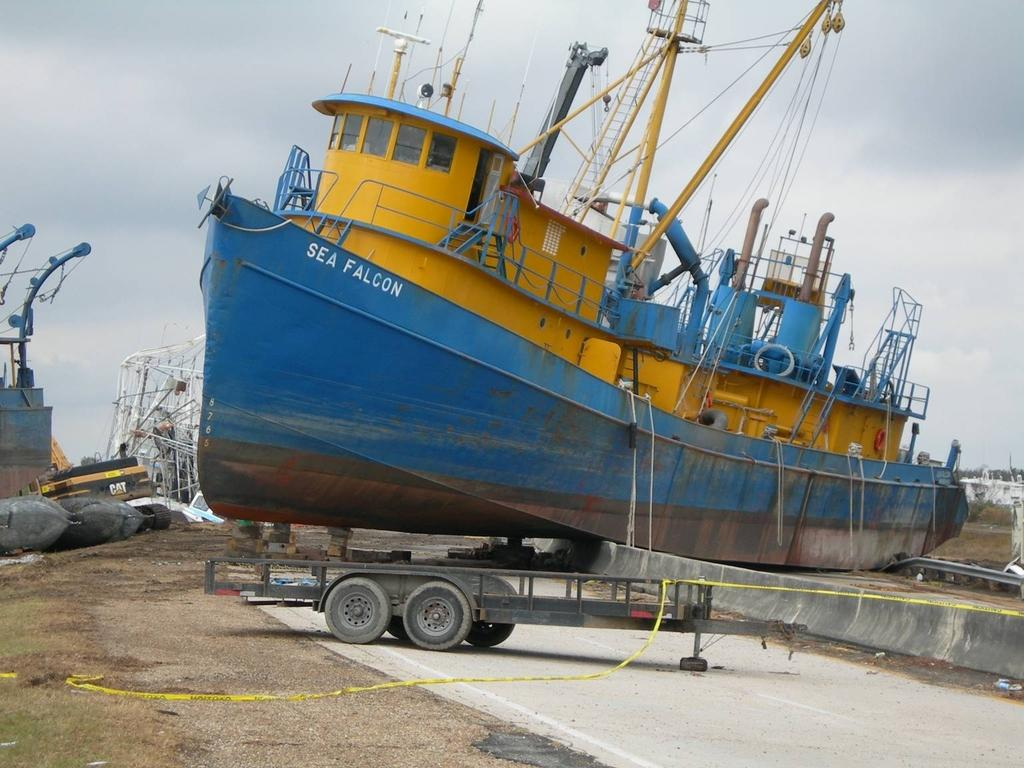<image>
Give a short and clear explanation of the subsequent image. A blue and yellow ship on land, it has the name Sea Falcon on it. 